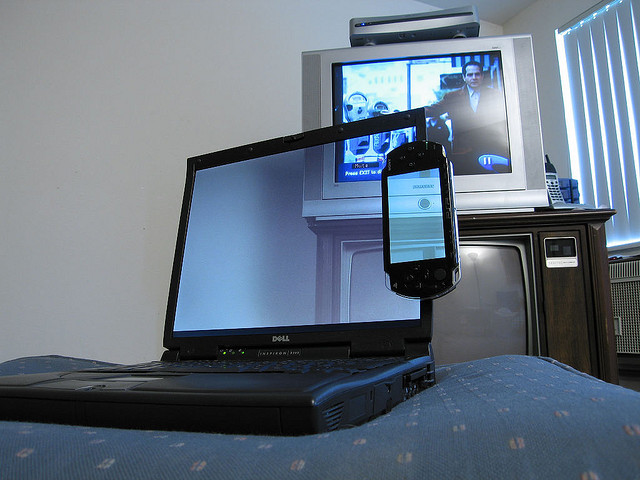Identify the text contained in this image. DeLL 